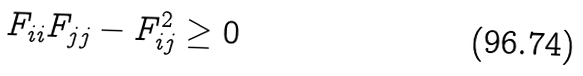<formula> <loc_0><loc_0><loc_500><loc_500>F _ { i i } F _ { j j } - F _ { i j } ^ { 2 } \geq 0</formula> 